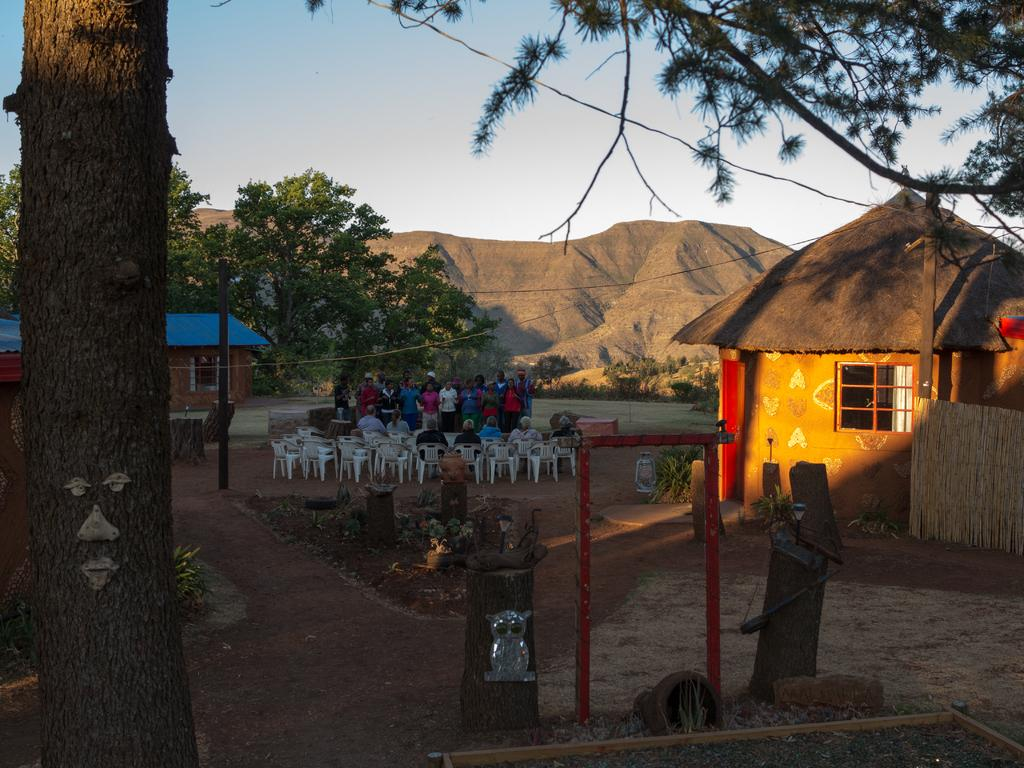What can be seen in the sky in the image? The sky is visible in the image, but no specific details about the sky are mentioned in the facts. What type of vegetation is present in the image? There are trees in the image. What type of structures can be seen in the image? There are houses in the image. What type of furniture is present in the image? Chairs are present in the image. What are the people in the image doing? There are people sitting and standing in the image. What other objects can be seen in the image? There are other objects in the image, but no specific details are provided. What type of error can be seen in the image? There is no mention of an error in the image. What actor is present in the image? There is no mention of an actor in the image. 